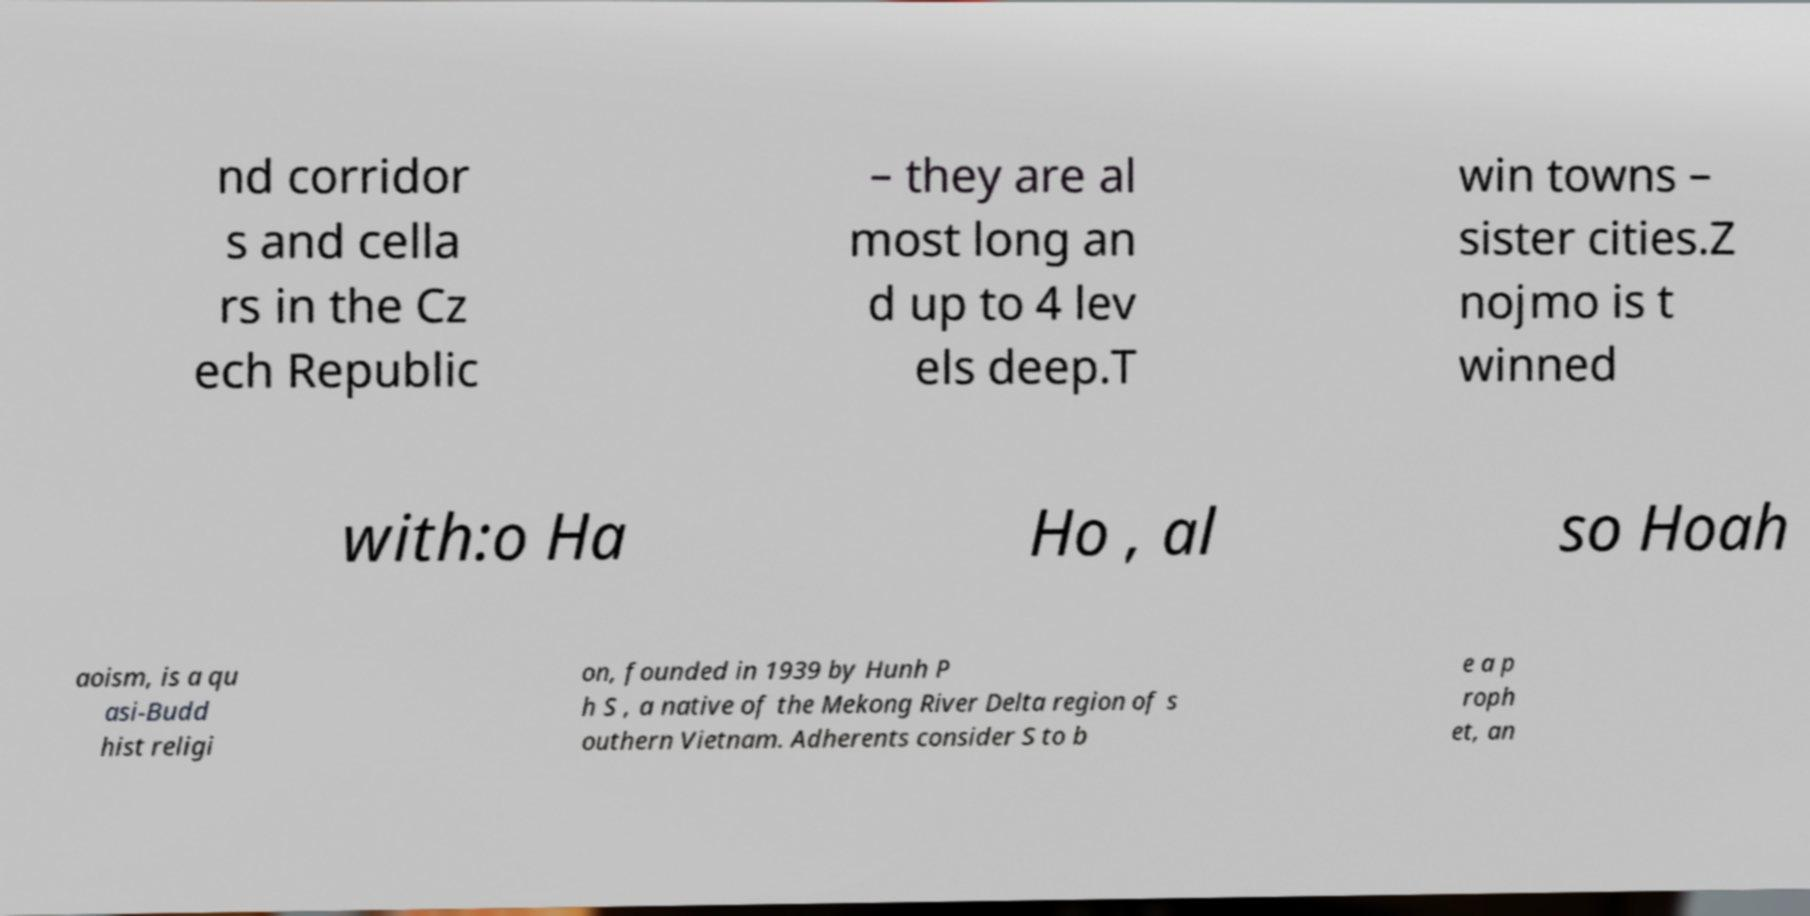Could you assist in decoding the text presented in this image and type it out clearly? nd corridor s and cella rs in the Cz ech Republic – they are al most long an d up to 4 lev els deep.T win towns – sister cities.Z nojmo is t winned with:o Ha Ho , al so Hoah aoism, is a qu asi-Budd hist religi on, founded in 1939 by Hunh P h S , a native of the Mekong River Delta region of s outhern Vietnam. Adherents consider S to b e a p roph et, an 